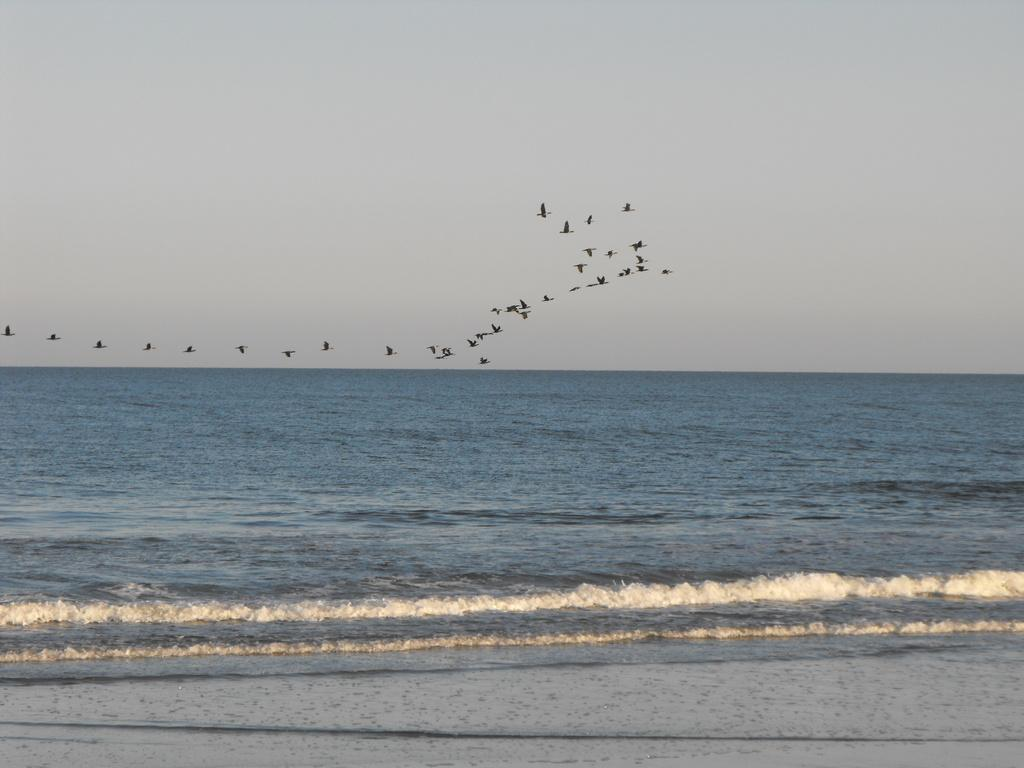What can be seen in the background of the image? The sky is visible in the background of the image. What is happening in the sky in the image? There are birds flying in the image. What is the primary subject of the image? The image is mainly focused on the sea. What advice is the snake giving to the birds in the image? There is no snake present in the image, so no advice can be given. 